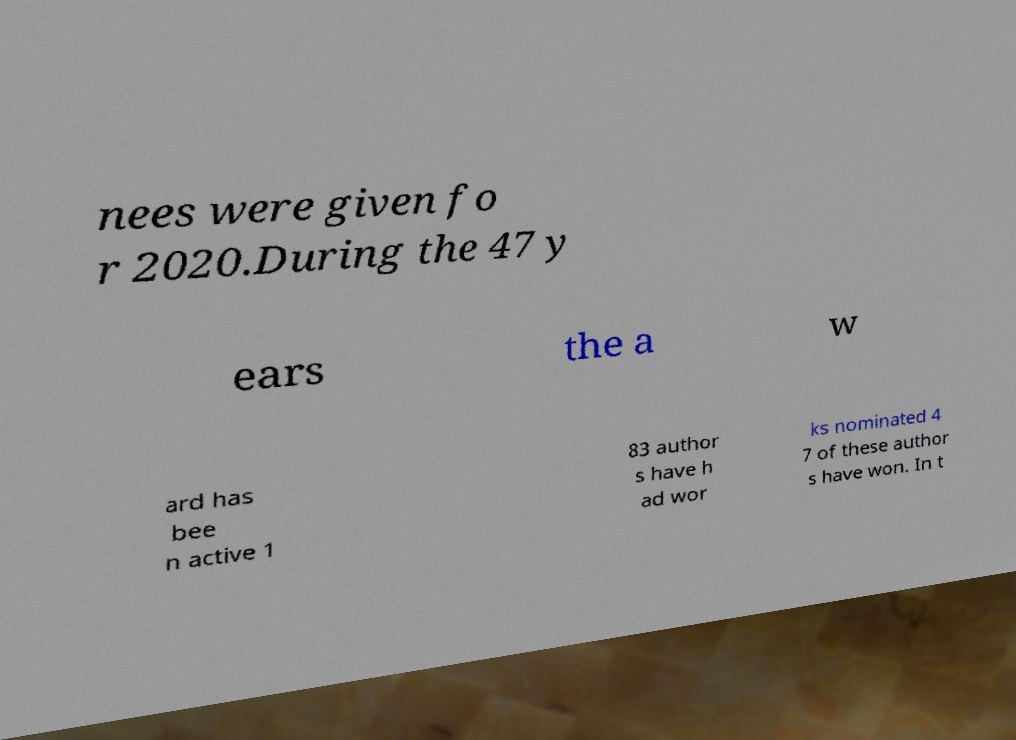What messages or text are displayed in this image? I need them in a readable, typed format. nees were given fo r 2020.During the 47 y ears the a w ard has bee n active 1 83 author s have h ad wor ks nominated 4 7 of these author s have won. In t 